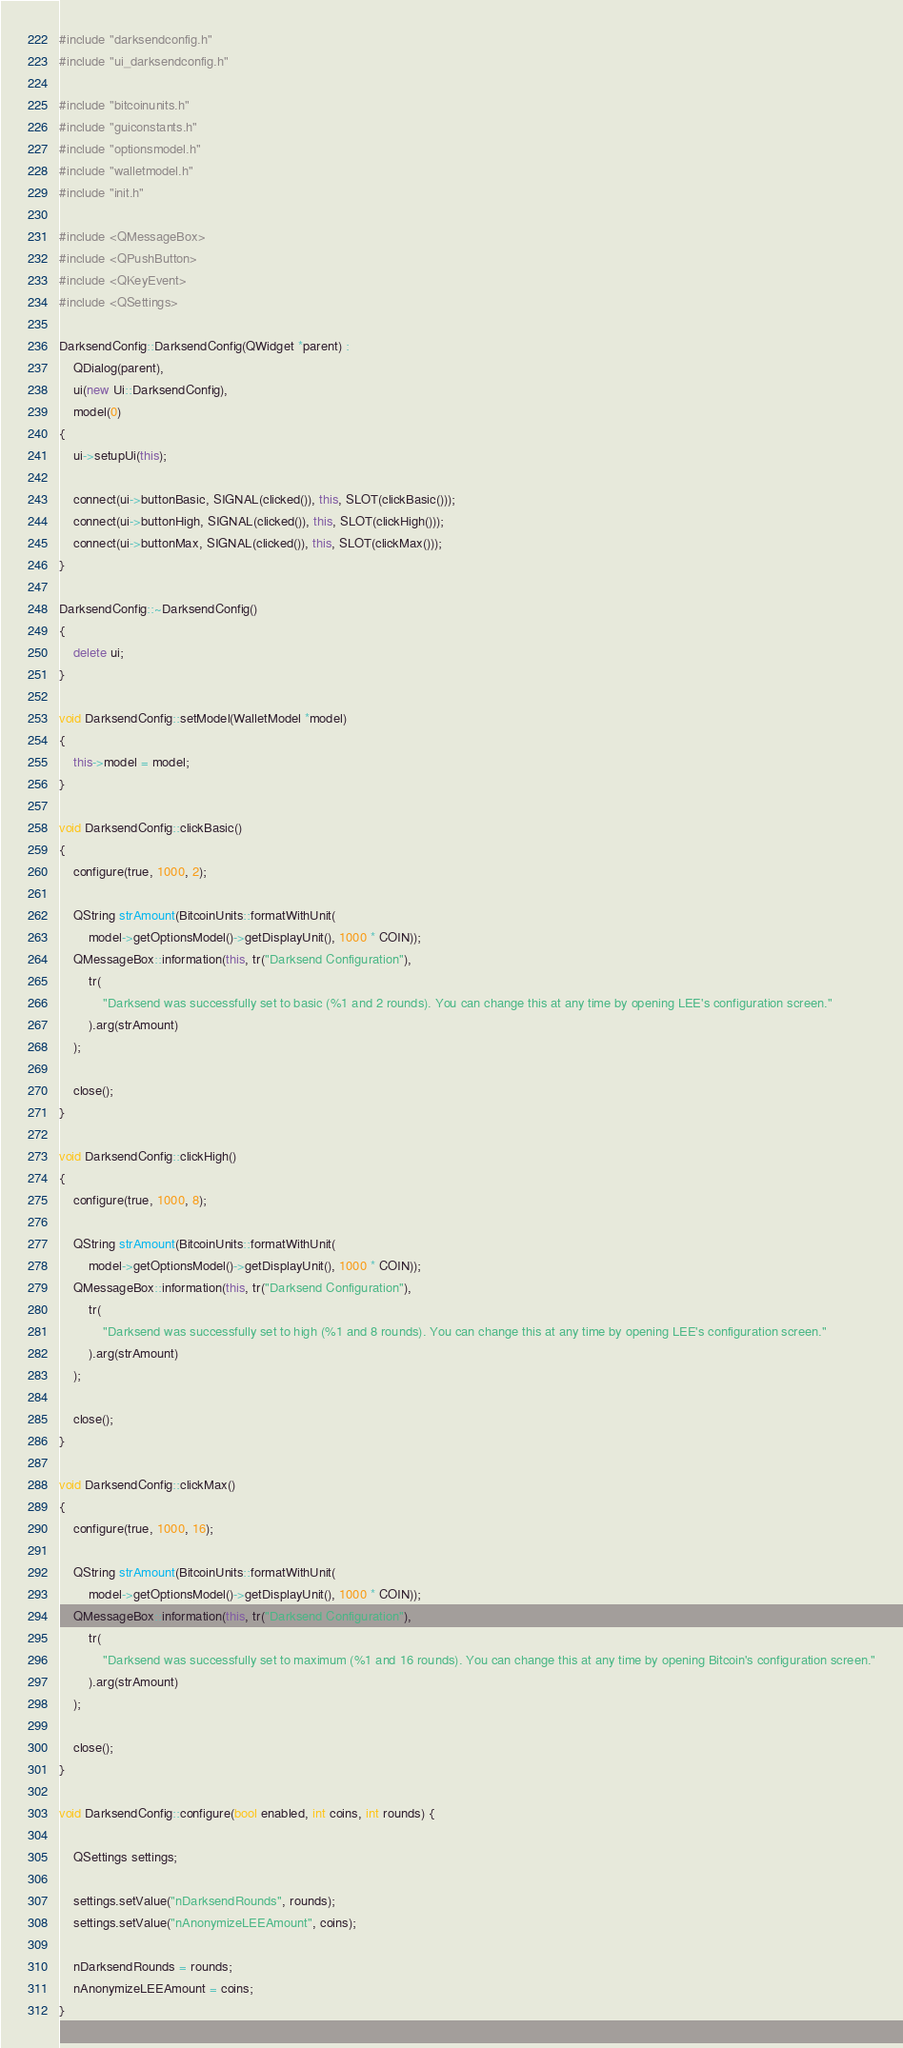<code> <loc_0><loc_0><loc_500><loc_500><_C++_>#include "darksendconfig.h"
#include "ui_darksendconfig.h"

#include "bitcoinunits.h"
#include "guiconstants.h"
#include "optionsmodel.h"
#include "walletmodel.h"
#include "init.h"

#include <QMessageBox>
#include <QPushButton>
#include <QKeyEvent>
#include <QSettings>

DarksendConfig::DarksendConfig(QWidget *parent) :
    QDialog(parent),
    ui(new Ui::DarksendConfig),
    model(0)
{
    ui->setupUi(this);

    connect(ui->buttonBasic, SIGNAL(clicked()), this, SLOT(clickBasic()));
    connect(ui->buttonHigh, SIGNAL(clicked()), this, SLOT(clickHigh()));
    connect(ui->buttonMax, SIGNAL(clicked()), this, SLOT(clickMax()));
}

DarksendConfig::~DarksendConfig()
{
    delete ui;
}

void DarksendConfig::setModel(WalletModel *model)
{
    this->model = model;
}

void DarksendConfig::clickBasic()
{
    configure(true, 1000, 2);

    QString strAmount(BitcoinUnits::formatWithUnit(
        model->getOptionsModel()->getDisplayUnit(), 1000 * COIN));
    QMessageBox::information(this, tr("Darksend Configuration"),
        tr(
            "Darksend was successfully set to basic (%1 and 2 rounds). You can change this at any time by opening LEE's configuration screen."
        ).arg(strAmount)
    );

    close();
}

void DarksendConfig::clickHigh()
{
    configure(true, 1000, 8);

    QString strAmount(BitcoinUnits::formatWithUnit(
        model->getOptionsModel()->getDisplayUnit(), 1000 * COIN));
    QMessageBox::information(this, tr("Darksend Configuration"),
        tr(
            "Darksend was successfully set to high (%1 and 8 rounds). You can change this at any time by opening LEE's configuration screen."
        ).arg(strAmount)
    );

    close();
}

void DarksendConfig::clickMax()
{
    configure(true, 1000, 16);

    QString strAmount(BitcoinUnits::formatWithUnit(
        model->getOptionsModel()->getDisplayUnit(), 1000 * COIN));
    QMessageBox::information(this, tr("Darksend Configuration"),
        tr(
            "Darksend was successfully set to maximum (%1 and 16 rounds). You can change this at any time by opening Bitcoin's configuration screen."
        ).arg(strAmount)
    );

    close();
}

void DarksendConfig::configure(bool enabled, int coins, int rounds) {

    QSettings settings;

    settings.setValue("nDarksendRounds", rounds);
    settings.setValue("nAnonymizeLEEAmount", coins);

    nDarksendRounds = rounds;
    nAnonymizeLEEAmount = coins;
}
</code> 